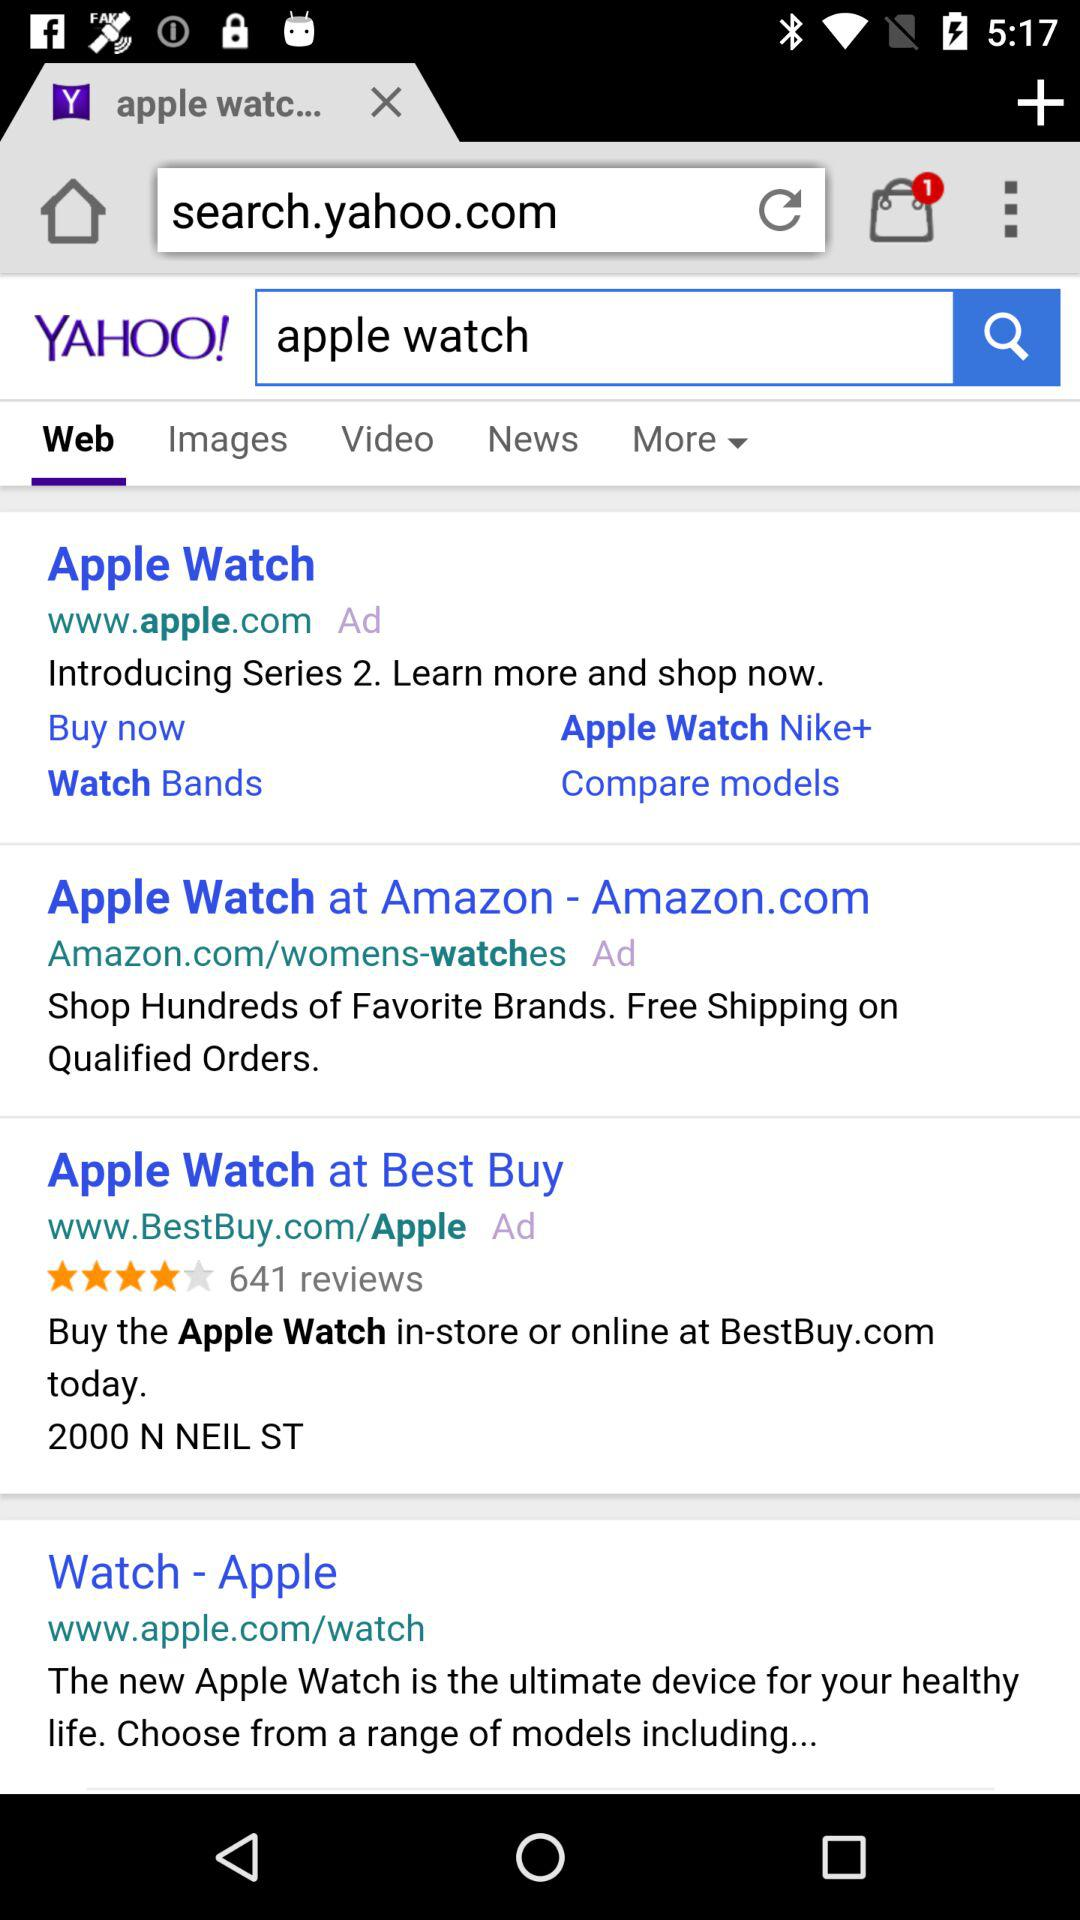What is the number of series? The series number is 2. 